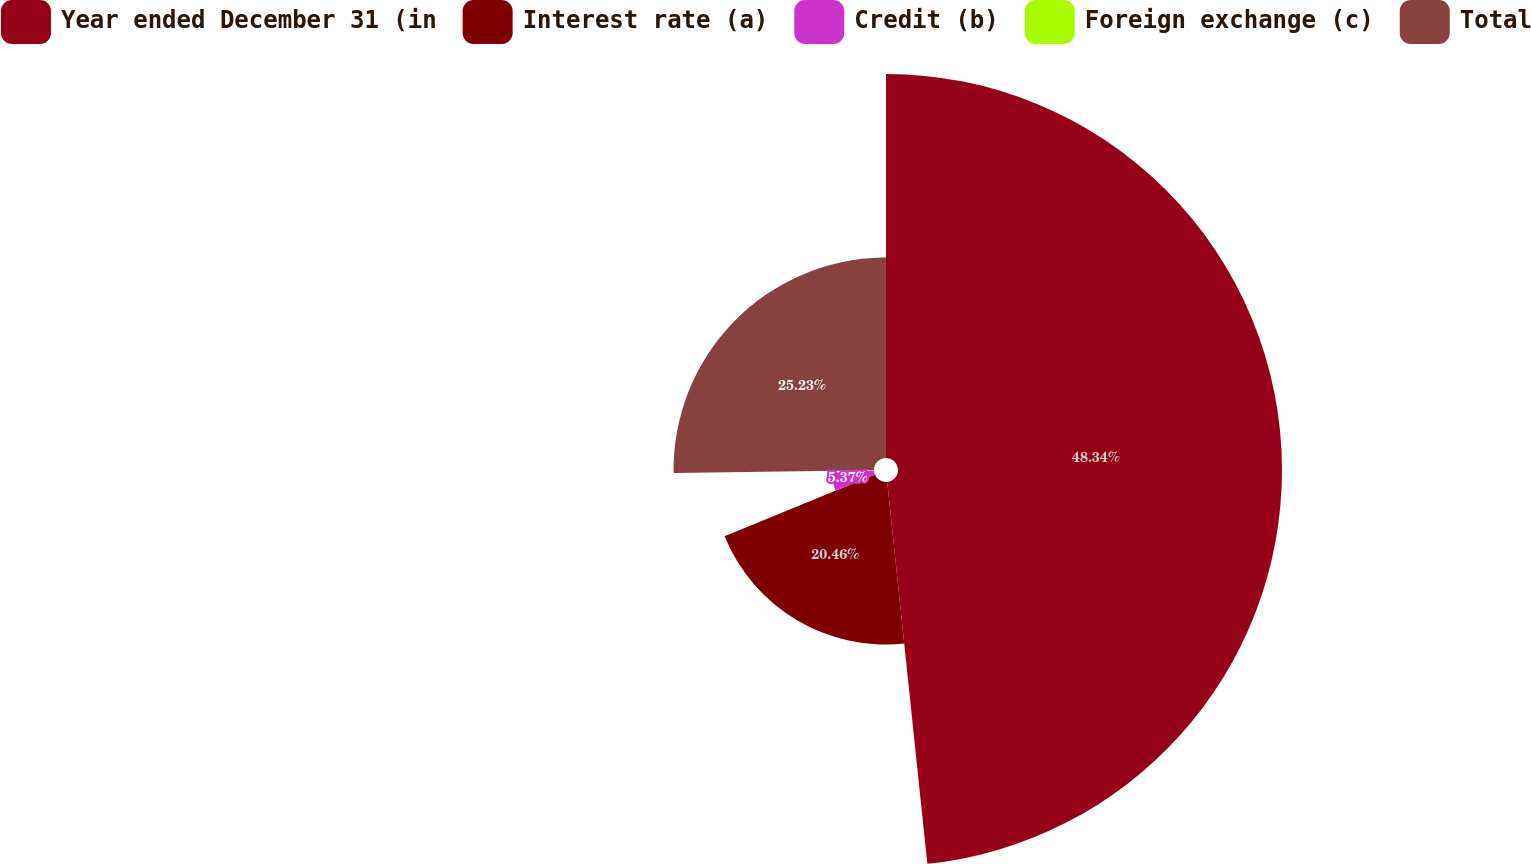<chart> <loc_0><loc_0><loc_500><loc_500><pie_chart><fcel>Year ended December 31 (in<fcel>Interest rate (a)<fcel>Credit (b)<fcel>Foreign exchange (c)<fcel>Total<nl><fcel>48.33%<fcel>20.46%<fcel>5.37%<fcel>0.6%<fcel>25.23%<nl></chart> 